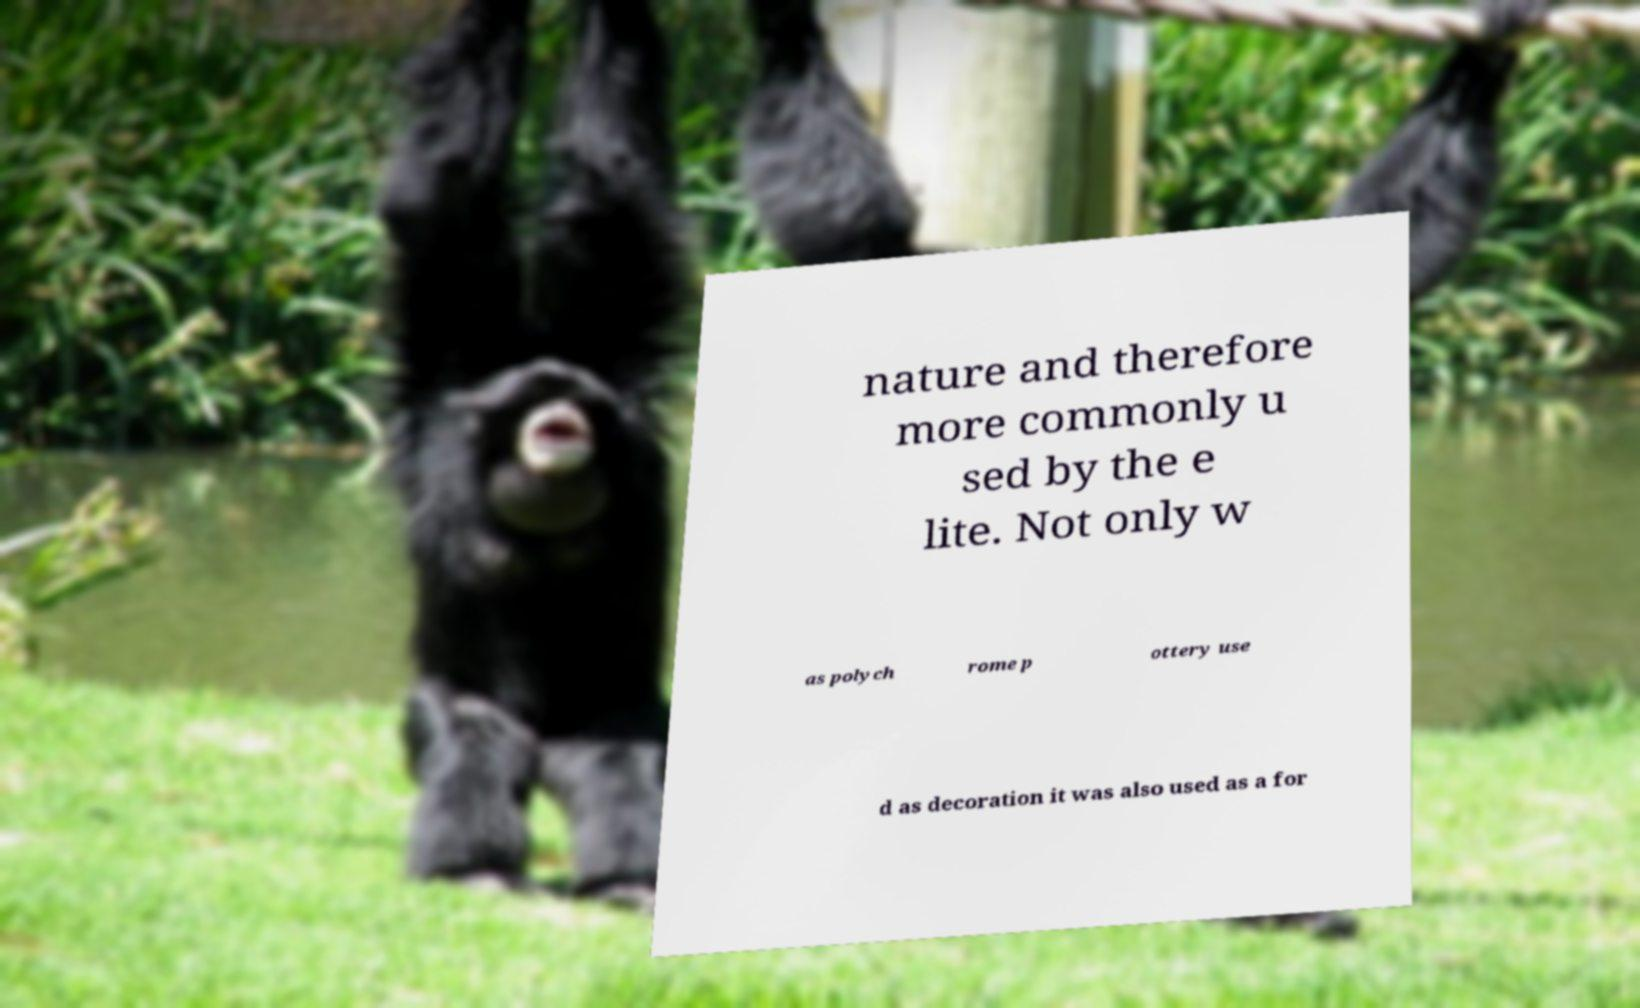Can you read and provide the text displayed in the image?This photo seems to have some interesting text. Can you extract and type it out for me? nature and therefore more commonly u sed by the e lite. Not only w as polych rome p ottery use d as decoration it was also used as a for 